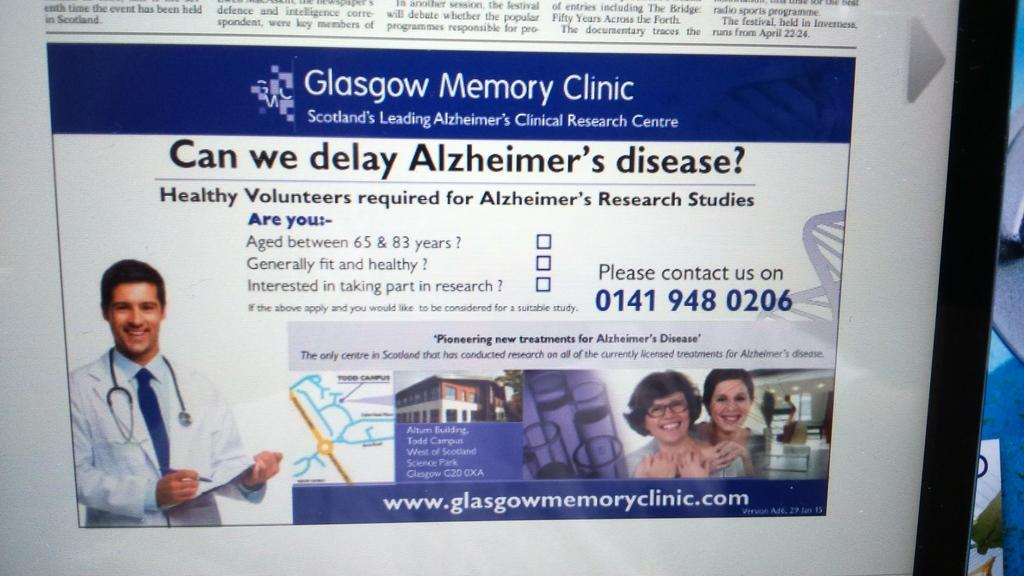What is the main feature of the image? There is a screen in the image. What can be seen on the screen? Text is visible on the screen, along with people and images. Can you describe the content of the screen? The screen displays text, people, and images. What is located on the right side of the image? There are objects on the right side of the image. Where is the bucket located in the image? There is no bucket present in the image. Can you describe the haircut of the person on the screen? There is no person getting a haircut on the screen; the image only shows text, people, and images on the screen. 